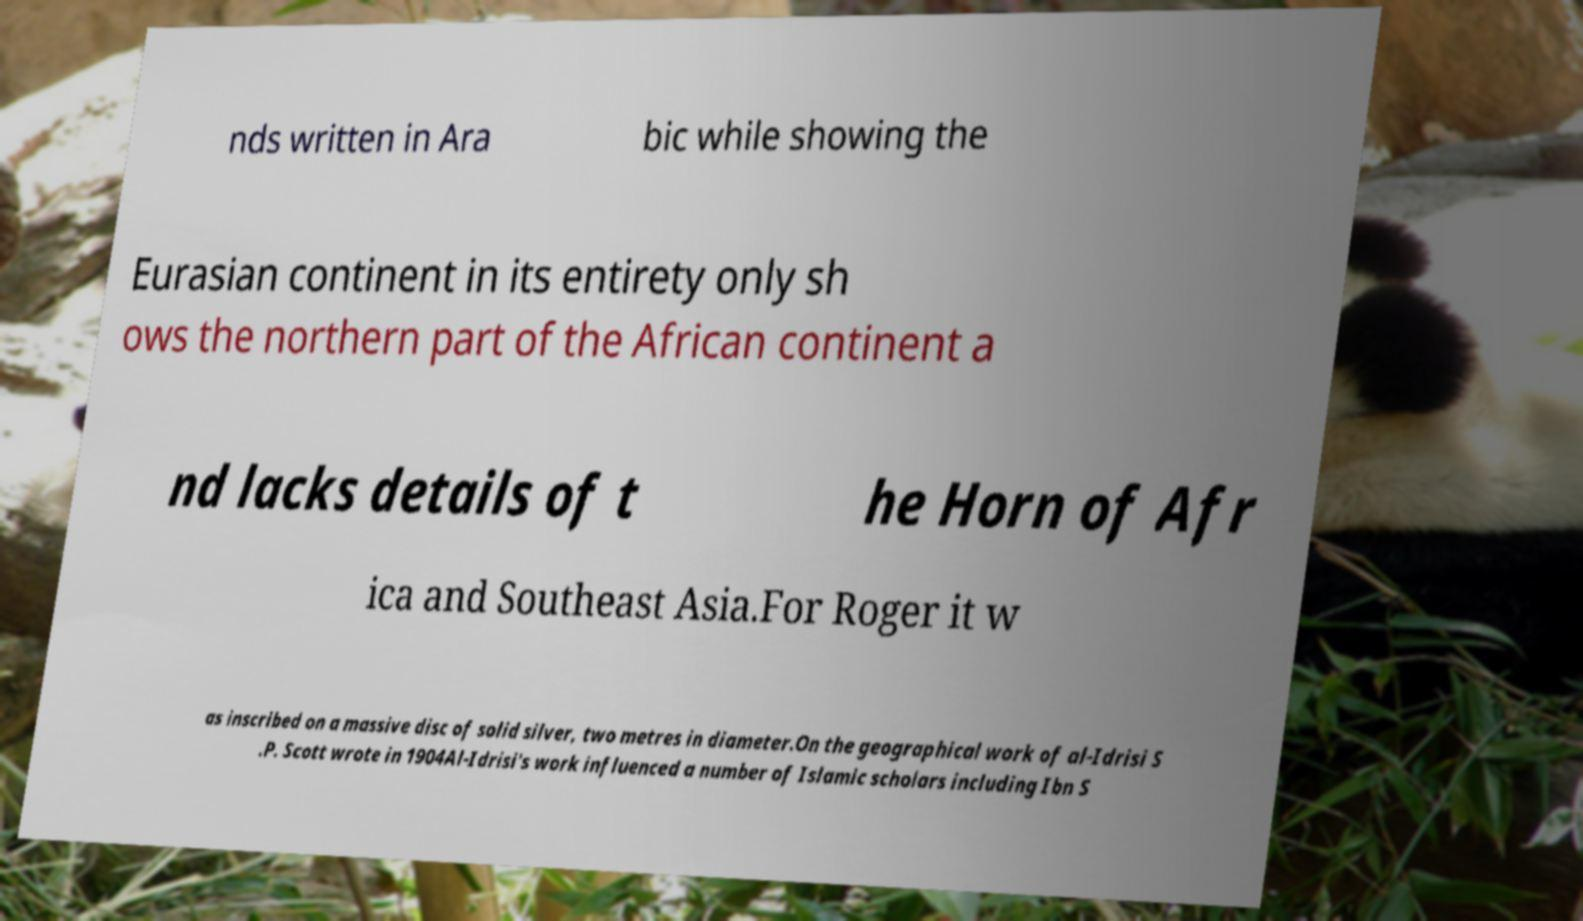Can you accurately transcribe the text from the provided image for me? nds written in Ara bic while showing the Eurasian continent in its entirety only sh ows the northern part of the African continent a nd lacks details of t he Horn of Afr ica and Southeast Asia.For Roger it w as inscribed on a massive disc of solid silver, two metres in diameter.On the geographical work of al-Idrisi S .P. Scott wrote in 1904Al-Idrisi's work influenced a number of Islamic scholars including Ibn S 